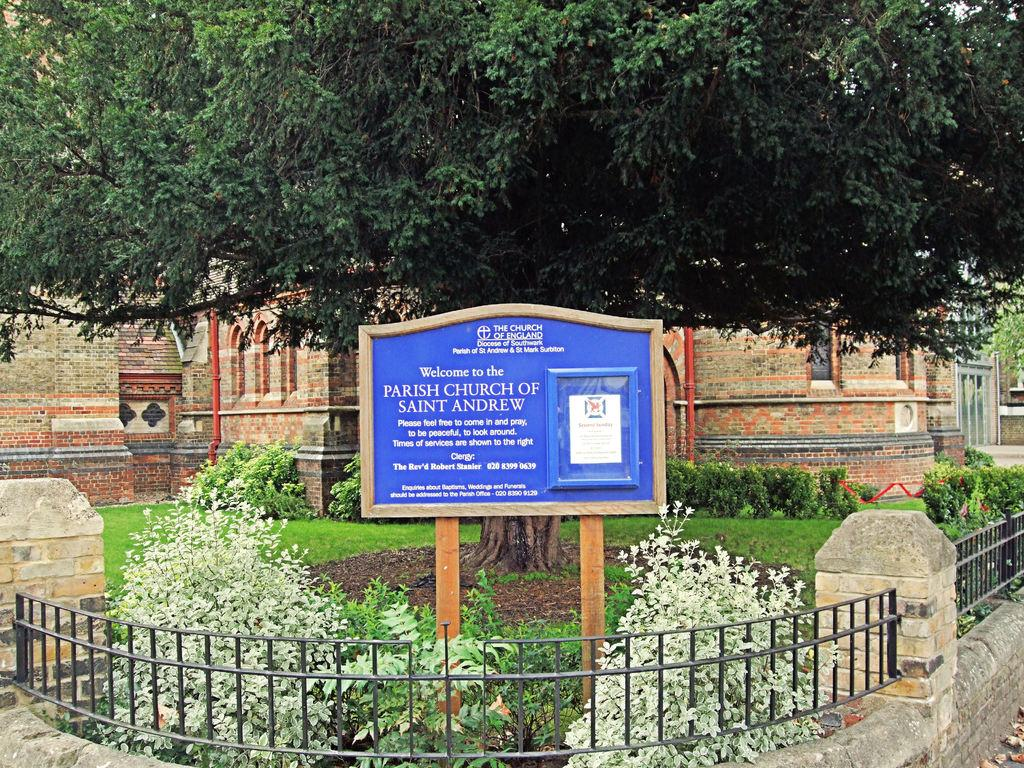What structure is the main subject of the image? There is a building in the image. What is located in front of the building? There is a tree in front of the building. What is placed in front of the tree? There is a board in front of the tree. What is in front of the board? There is a fence in front of the board. What is in front of the fence? There are plants in front of the fence. Can you see any giraffes walking through the sleet in the image? There are no giraffes or sleet present in the image. 